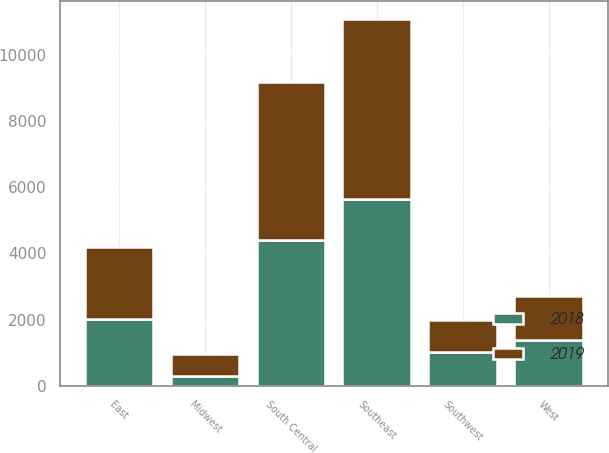Convert chart to OTSL. <chart><loc_0><loc_0><loc_500><loc_500><stacked_bar_chart><ecel><fcel>East<fcel>Midwest<fcel>Southeast<fcel>South Central<fcel>Southwest<fcel>West<nl><fcel>2019<fcel>2155<fcel>680<fcel>5410<fcel>4751<fcel>969<fcel>1323<nl><fcel>2018<fcel>2031<fcel>299<fcel>5655<fcel>4408<fcel>1031<fcel>1378<nl></chart> 